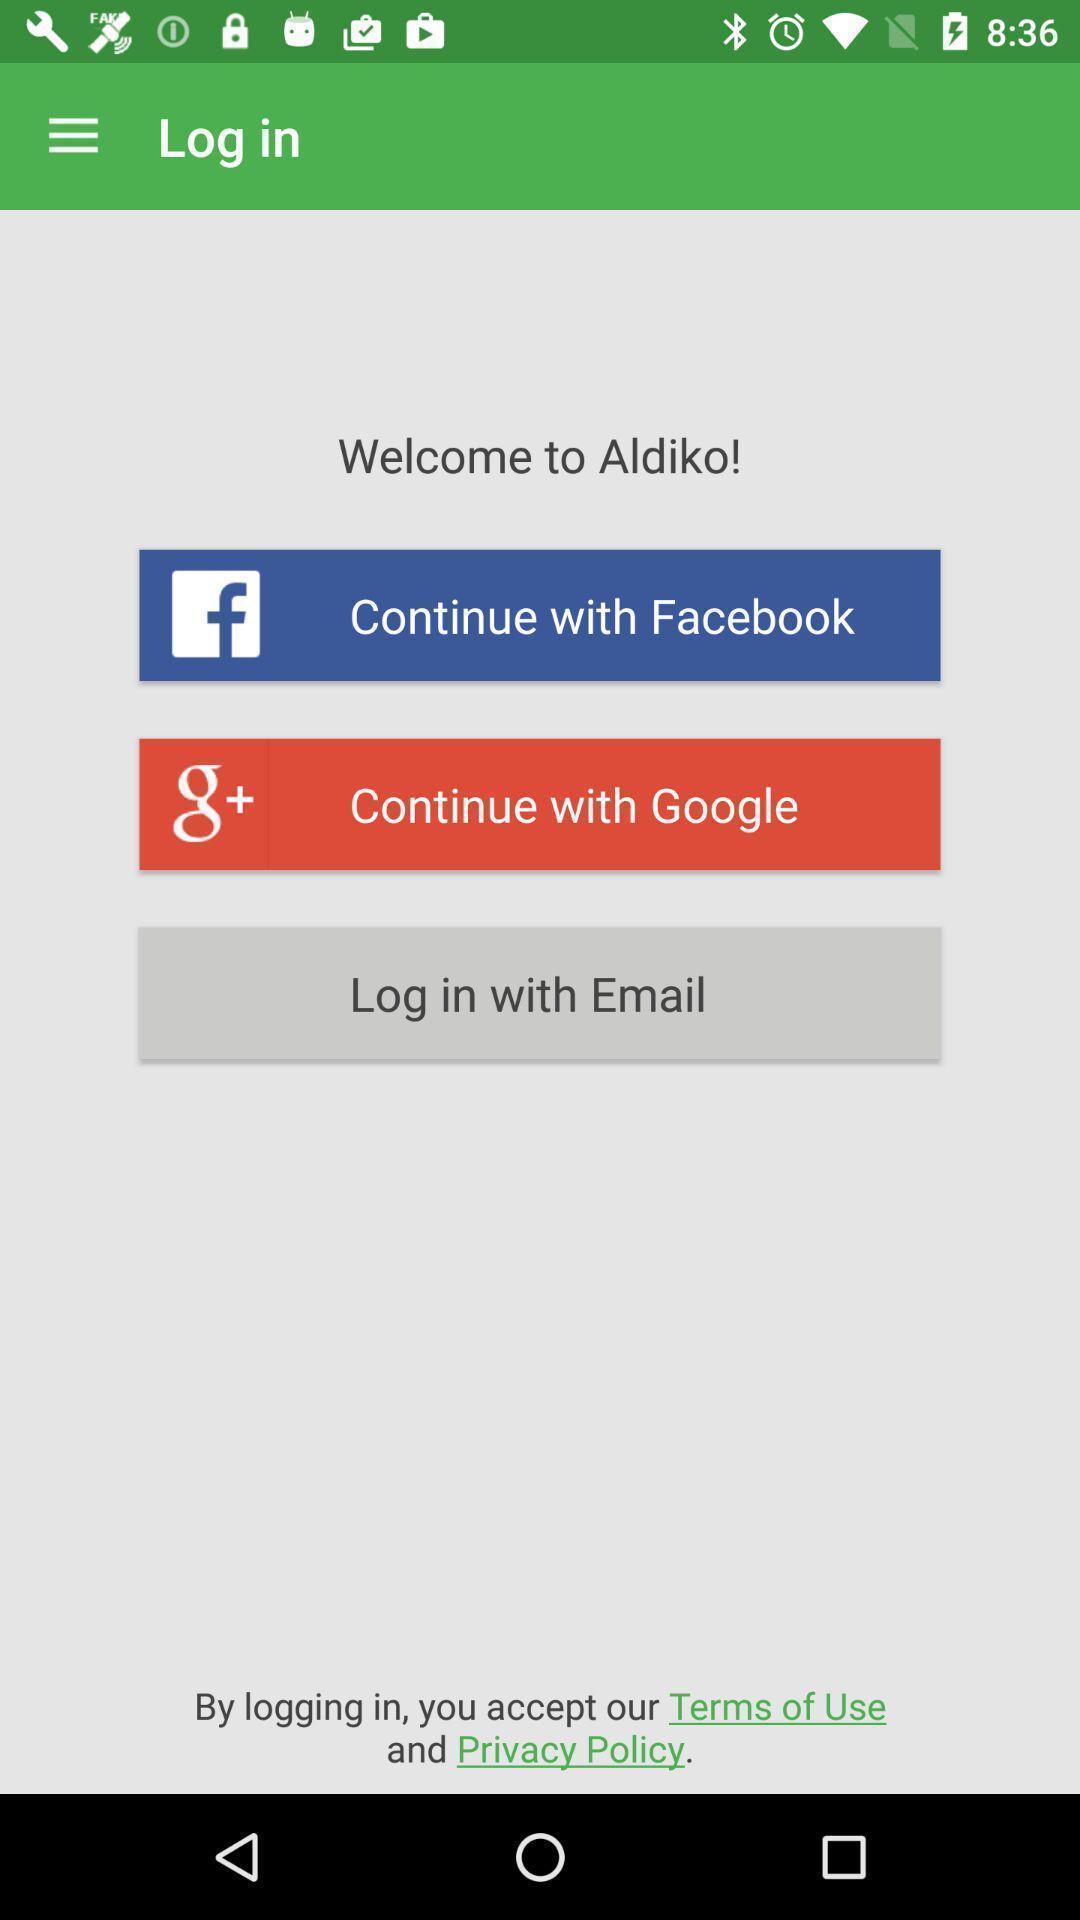Give me a narrative description of this picture. Welcome page. 